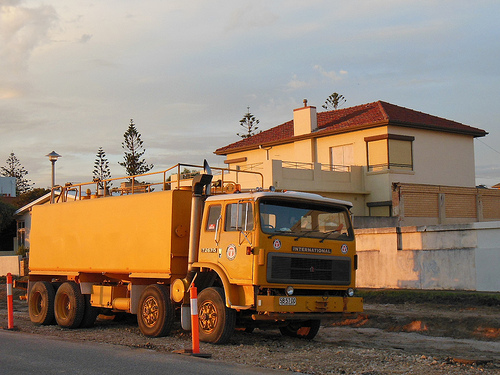Describe the environment surrounding the truck, focusing on how it might influence the truck's function. The truck is parked on a gravel lot, surrounded by safety cones and a cement fence, suggesting it is likely used in construction or municipal maintenance. The open environment and absence of dense traffic indicate it may regularly operate in less congested, possibly suburban or semi-rural areas. Are there other vehicles or equipment suggested in the scene that support this truck's operation? While not directly visible, the presence of safety cones and the heavy-duty design of the truck itself imply that other vehicles or machinery, like excavators or dump trucks, may operate nearby as part of larger construction or maintenance projects. 